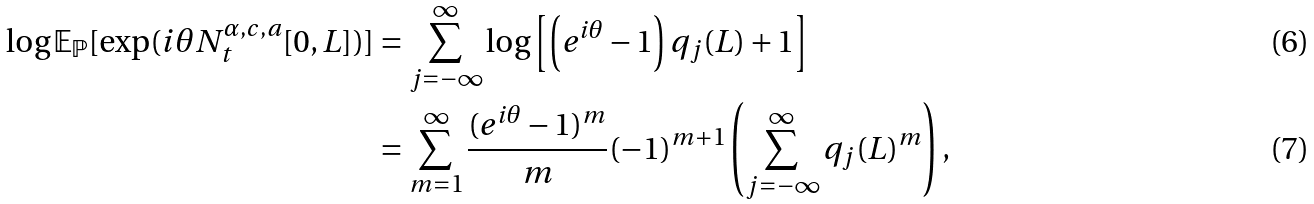Convert formula to latex. <formula><loc_0><loc_0><loc_500><loc_500>\log \mathbb { E } _ { \mathbb { P } } [ \exp ( i \theta N _ { t } ^ { \alpha , c , a } [ 0 , L ] ) ] & = \sum _ { j = - \infty } ^ { \infty } \log \left [ \left ( e ^ { i \theta } - 1 \right ) q _ { j } ( L ) + 1 \right ] \\ & = \sum _ { m = 1 } ^ { \infty } \frac { ( e ^ { i \theta } - 1 ) ^ { m } } { m } ( - 1 ) ^ { m + 1 } \left ( \sum _ { j = - \infty } ^ { \infty } q _ { j } ( L ) ^ { m } \right ) ,</formula> 